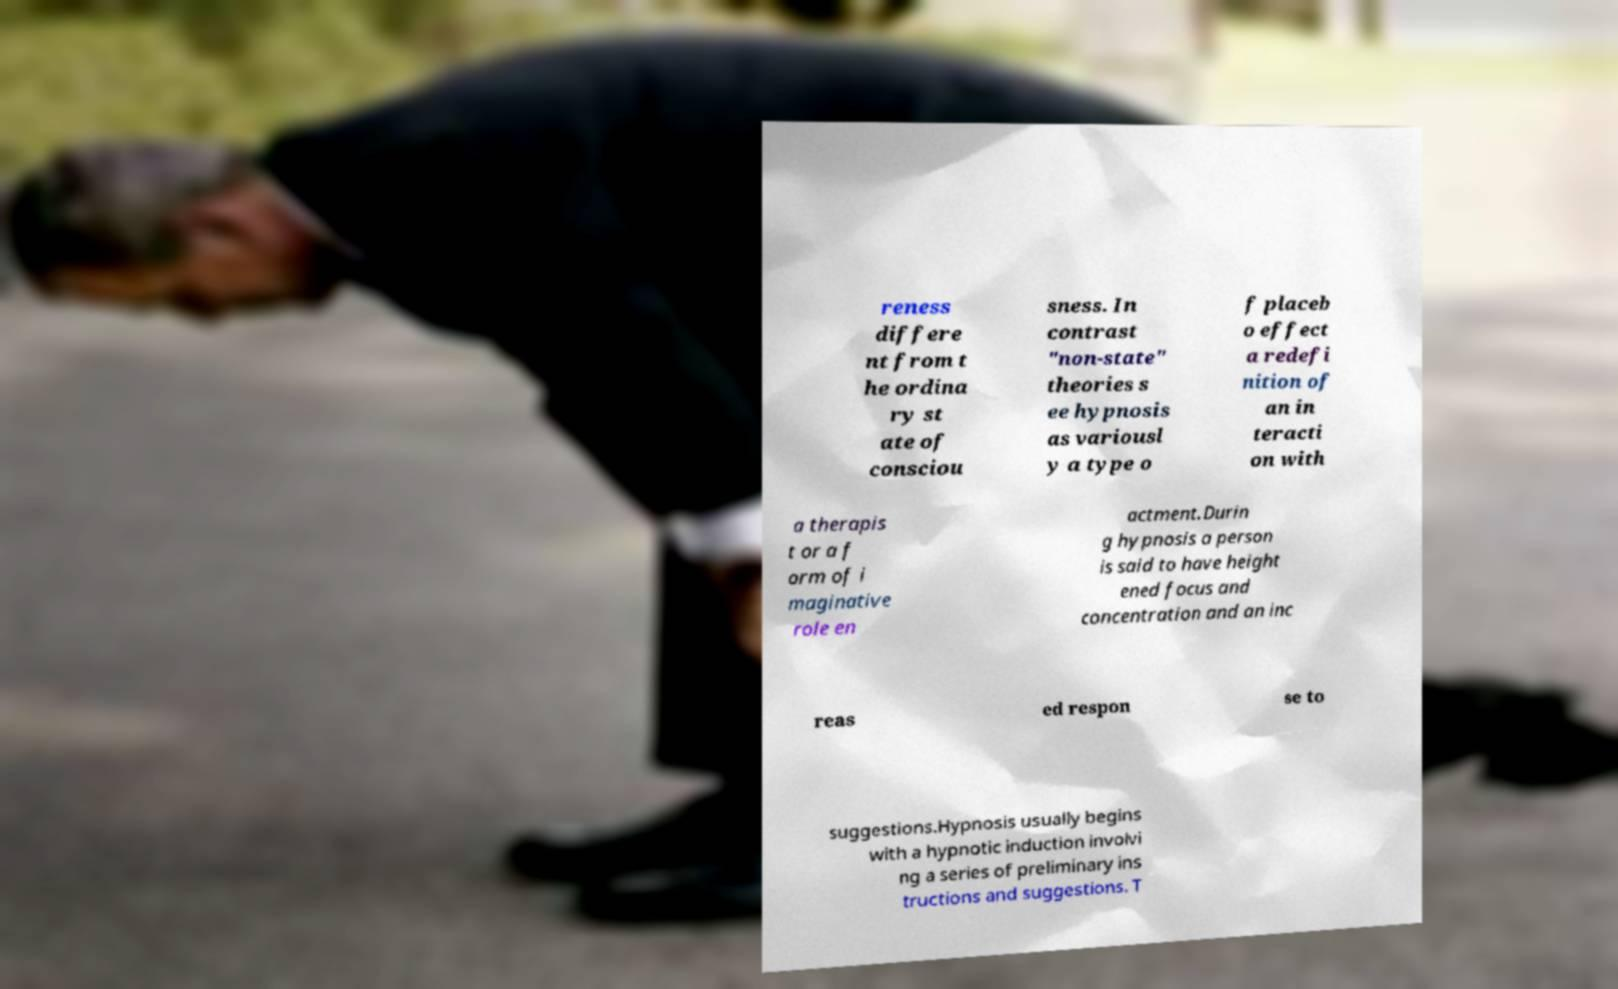Can you read and provide the text displayed in the image?This photo seems to have some interesting text. Can you extract and type it out for me? reness differe nt from t he ordina ry st ate of consciou sness. In contrast "non-state" theories s ee hypnosis as variousl y a type o f placeb o effect a redefi nition of an in teracti on with a therapis t or a f orm of i maginative role en actment.Durin g hypnosis a person is said to have height ened focus and concentration and an inc reas ed respon se to suggestions.Hypnosis usually begins with a hypnotic induction involvi ng a series of preliminary ins tructions and suggestions. T 